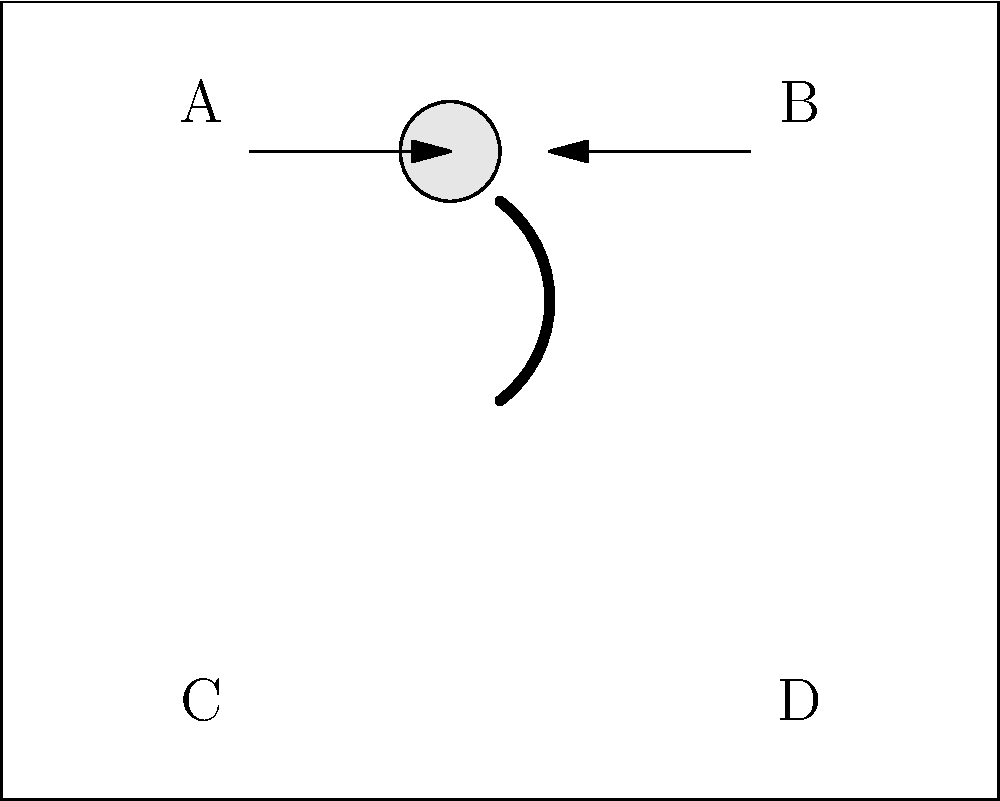In the diagram above, which position represents the safest sleeping position for an infant in a crib? To determine the safest sleeping position for an infant, let's consider each option:

1. Position A: This is on the baby's side, which is not recommended as it can lead to the baby rolling onto their stomach.

2. Position B: This is also on the baby's side, facing the other direction. It carries the same risks as position A.

3. Position C: This position would represent the baby sleeping on their stomach, which is highly discouraged due to the increased risk of Sudden Infant Death Syndrome (SIDS).

4. Position D: This position represents the baby sleeping on their back. 

The American Academy of Pediatrics (AAP) recommends that infants should be placed on their backs for every sleep until they are 1 year old. This position, known as the supine position, is associated with the lowest risk of SIDS.

The diagram shows the baby in the center of the crib, which is correct. The infant should be placed on a firm sleep surface, without any soft objects, toys, crib bumpers, or loose bedding.

Therefore, position D, which represents the baby sleeping on their back, is the safest sleeping position for an infant in a crib.
Answer: D 